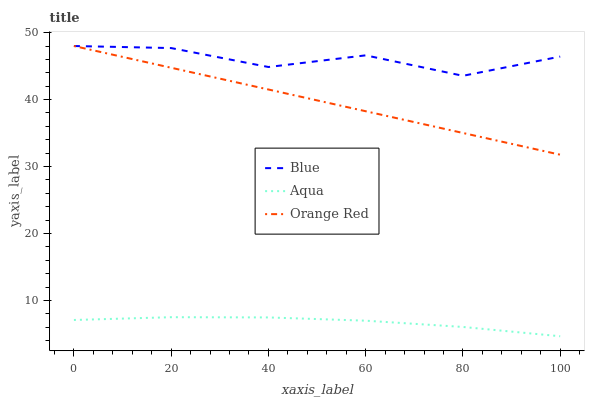Does Aqua have the minimum area under the curve?
Answer yes or no. Yes. Does Blue have the maximum area under the curve?
Answer yes or no. Yes. Does Orange Red have the minimum area under the curve?
Answer yes or no. No. Does Orange Red have the maximum area under the curve?
Answer yes or no. No. Is Orange Red the smoothest?
Answer yes or no. Yes. Is Blue the roughest?
Answer yes or no. Yes. Is Aqua the smoothest?
Answer yes or no. No. Is Aqua the roughest?
Answer yes or no. No. Does Aqua have the lowest value?
Answer yes or no. Yes. Does Orange Red have the lowest value?
Answer yes or no. No. Does Orange Red have the highest value?
Answer yes or no. Yes. Does Aqua have the highest value?
Answer yes or no. No. Is Aqua less than Blue?
Answer yes or no. Yes. Is Blue greater than Aqua?
Answer yes or no. Yes. Does Orange Red intersect Blue?
Answer yes or no. Yes. Is Orange Red less than Blue?
Answer yes or no. No. Is Orange Red greater than Blue?
Answer yes or no. No. Does Aqua intersect Blue?
Answer yes or no. No. 